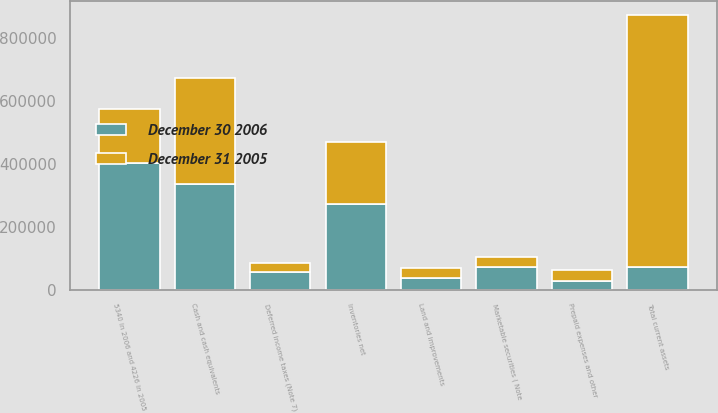Convert chart to OTSL. <chart><loc_0><loc_0><loc_500><loc_500><stacked_bar_chart><ecel><fcel>Cash and cash equivalents<fcel>Marketable securities ( Note<fcel>5340 in 2006 and 4226 in 2005<fcel>Inventories net<fcel>Deferred income taxes (Note 7)<fcel>Prepaid expenses and other<fcel>Total current assets<fcel>Land and improvements<nl><fcel>December 30 2006<fcel>337321<fcel>73033<fcel>403524<fcel>271008<fcel>55996<fcel>28202<fcel>73033<fcel>37103<nl><fcel>December 31 2005<fcel>334352<fcel>32050<fcel>170997<fcel>199841<fcel>29615<fcel>34312<fcel>801167<fcel>31075<nl></chart> 